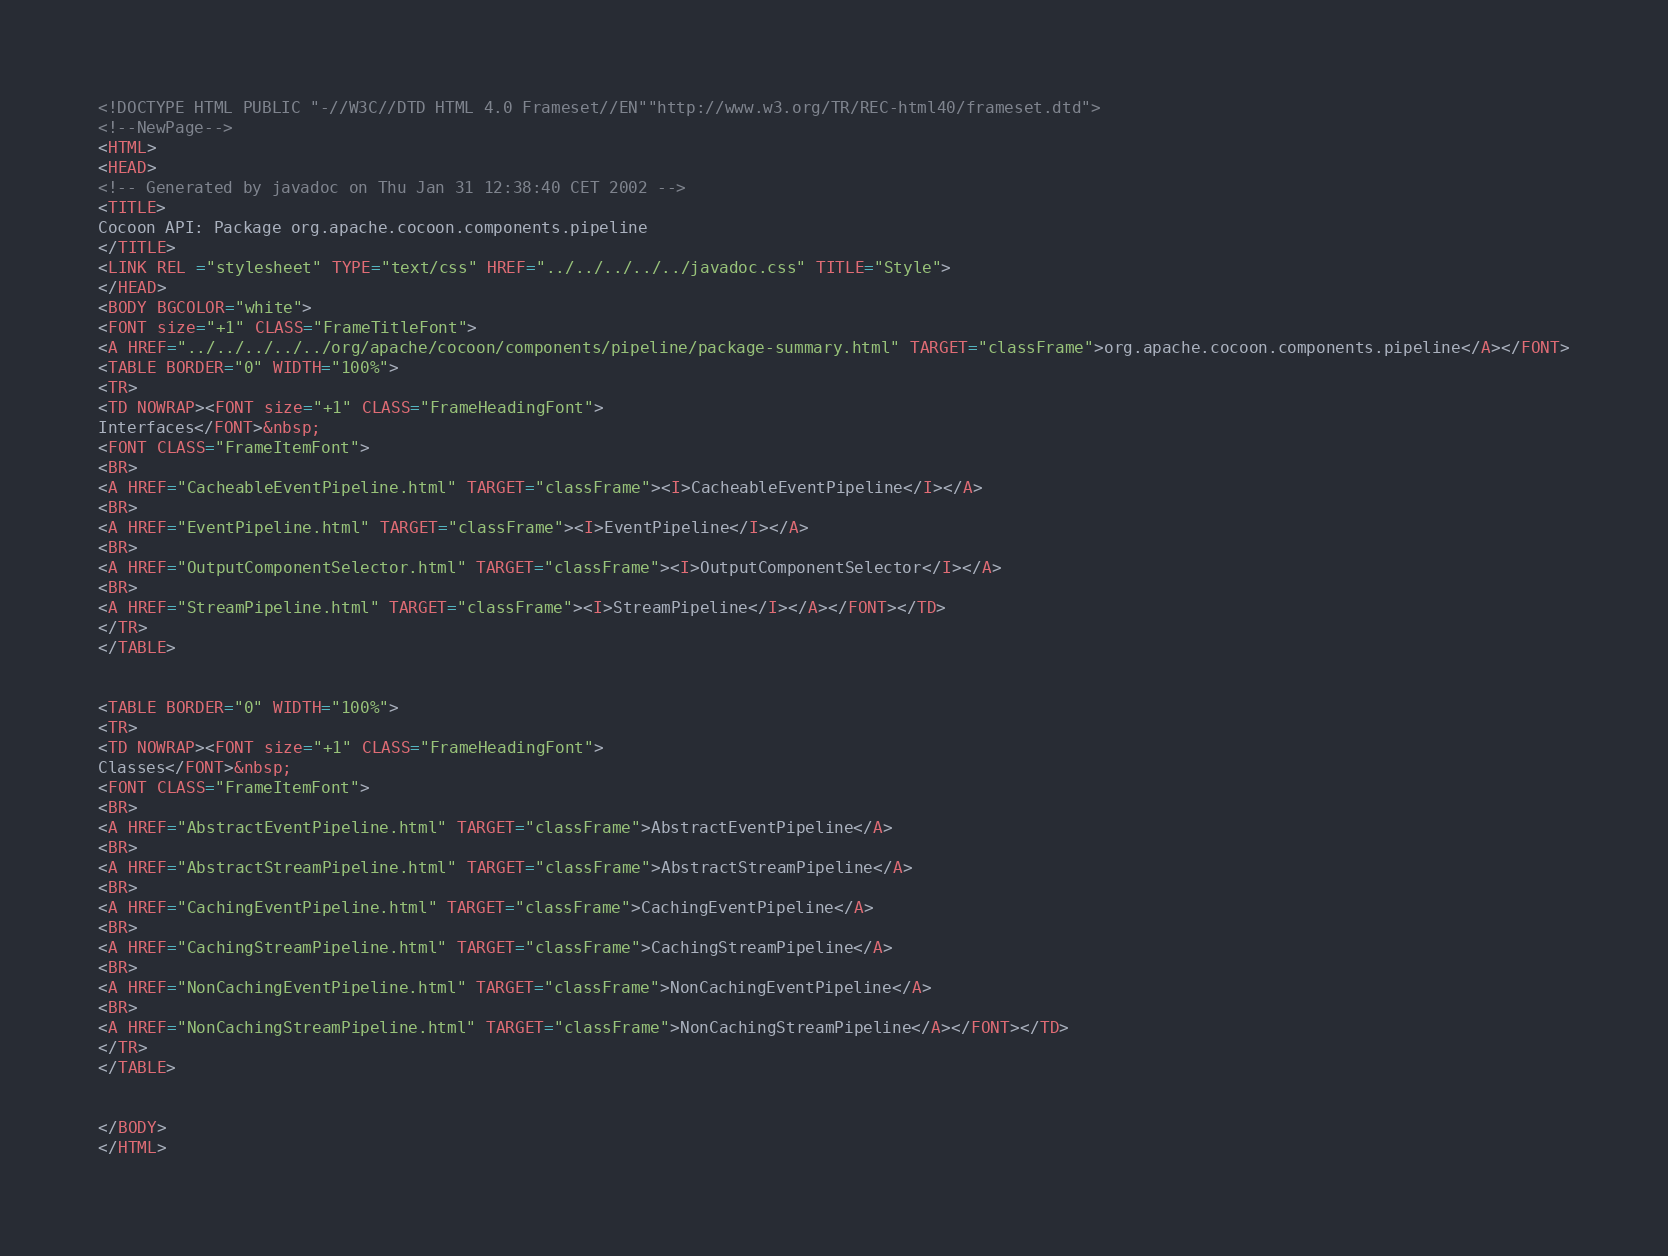Convert code to text. <code><loc_0><loc_0><loc_500><loc_500><_HTML_><!DOCTYPE HTML PUBLIC "-//W3C//DTD HTML 4.0 Frameset//EN""http://www.w3.org/TR/REC-html40/frameset.dtd">
<!--NewPage-->
<HTML>
<HEAD>
<!-- Generated by javadoc on Thu Jan 31 12:38:40 CET 2002 -->
<TITLE>
Cocoon API: Package org.apache.cocoon.components.pipeline
</TITLE>
<LINK REL ="stylesheet" TYPE="text/css" HREF="../../../../../javadoc.css" TITLE="Style">
</HEAD>
<BODY BGCOLOR="white">
<FONT size="+1" CLASS="FrameTitleFont">
<A HREF="../../../../../org/apache/cocoon/components/pipeline/package-summary.html" TARGET="classFrame">org.apache.cocoon.components.pipeline</A></FONT>
<TABLE BORDER="0" WIDTH="100%">
<TR>
<TD NOWRAP><FONT size="+1" CLASS="FrameHeadingFont">
Interfaces</FONT>&nbsp;
<FONT CLASS="FrameItemFont">
<BR>
<A HREF="CacheableEventPipeline.html" TARGET="classFrame"><I>CacheableEventPipeline</I></A>
<BR>
<A HREF="EventPipeline.html" TARGET="classFrame"><I>EventPipeline</I></A>
<BR>
<A HREF="OutputComponentSelector.html" TARGET="classFrame"><I>OutputComponentSelector</I></A>
<BR>
<A HREF="StreamPipeline.html" TARGET="classFrame"><I>StreamPipeline</I></A></FONT></TD>
</TR>
</TABLE>


<TABLE BORDER="0" WIDTH="100%">
<TR>
<TD NOWRAP><FONT size="+1" CLASS="FrameHeadingFont">
Classes</FONT>&nbsp;
<FONT CLASS="FrameItemFont">
<BR>
<A HREF="AbstractEventPipeline.html" TARGET="classFrame">AbstractEventPipeline</A>
<BR>
<A HREF="AbstractStreamPipeline.html" TARGET="classFrame">AbstractStreamPipeline</A>
<BR>
<A HREF="CachingEventPipeline.html" TARGET="classFrame">CachingEventPipeline</A>
<BR>
<A HREF="CachingStreamPipeline.html" TARGET="classFrame">CachingStreamPipeline</A>
<BR>
<A HREF="NonCachingEventPipeline.html" TARGET="classFrame">NonCachingEventPipeline</A>
<BR>
<A HREF="NonCachingStreamPipeline.html" TARGET="classFrame">NonCachingStreamPipeline</A></FONT></TD>
</TR>
</TABLE>


</BODY>
</HTML>
</code> 